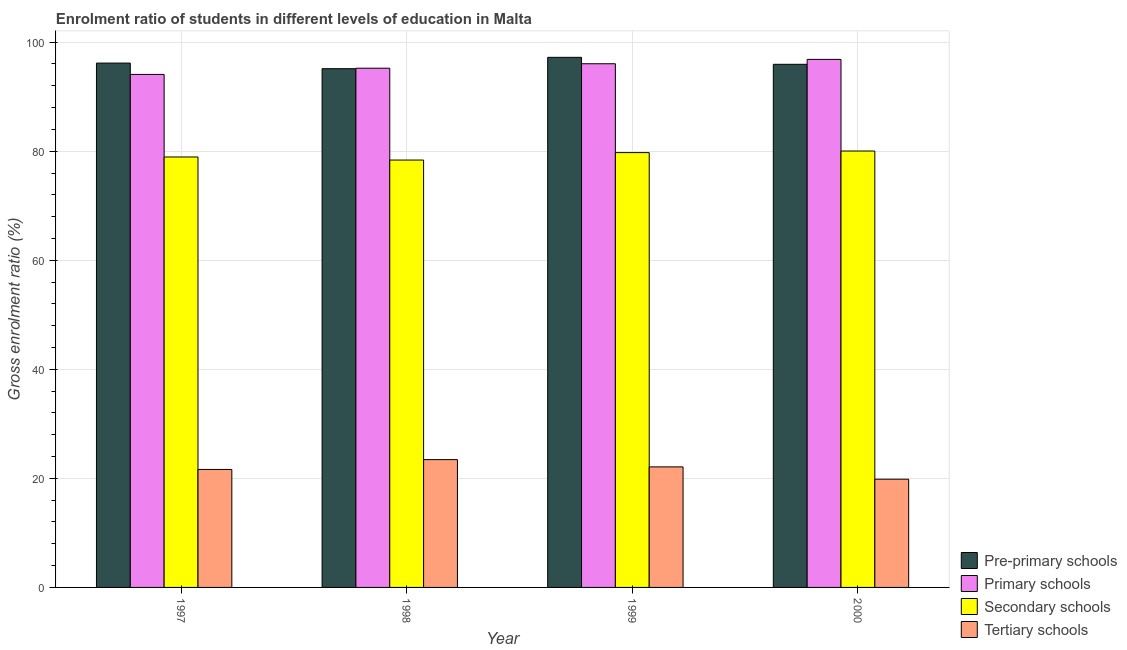How many bars are there on the 2nd tick from the right?
Your answer should be compact. 4. In how many cases, is the number of bars for a given year not equal to the number of legend labels?
Your response must be concise. 0. What is the gross enrolment ratio in pre-primary schools in 2000?
Offer a terse response. 95.94. Across all years, what is the maximum gross enrolment ratio in primary schools?
Your answer should be compact. 96.84. Across all years, what is the minimum gross enrolment ratio in tertiary schools?
Provide a short and direct response. 19.85. What is the total gross enrolment ratio in primary schools in the graph?
Your answer should be very brief. 382.19. What is the difference between the gross enrolment ratio in tertiary schools in 1998 and that in 1999?
Give a very brief answer. 1.33. What is the difference between the gross enrolment ratio in secondary schools in 1997 and the gross enrolment ratio in pre-primary schools in 1999?
Your answer should be compact. -0.8. What is the average gross enrolment ratio in primary schools per year?
Give a very brief answer. 95.55. In how many years, is the gross enrolment ratio in secondary schools greater than 64 %?
Provide a succinct answer. 4. What is the ratio of the gross enrolment ratio in secondary schools in 1997 to that in 1999?
Offer a very short reply. 0.99. What is the difference between the highest and the second highest gross enrolment ratio in primary schools?
Your answer should be compact. 0.8. What is the difference between the highest and the lowest gross enrolment ratio in primary schools?
Provide a succinct answer. 2.76. In how many years, is the gross enrolment ratio in pre-primary schools greater than the average gross enrolment ratio in pre-primary schools taken over all years?
Your answer should be compact. 2. Is the sum of the gross enrolment ratio in primary schools in 1997 and 1999 greater than the maximum gross enrolment ratio in tertiary schools across all years?
Your answer should be compact. Yes. Is it the case that in every year, the sum of the gross enrolment ratio in primary schools and gross enrolment ratio in pre-primary schools is greater than the sum of gross enrolment ratio in secondary schools and gross enrolment ratio in tertiary schools?
Your answer should be compact. Yes. What does the 2nd bar from the left in 1999 represents?
Your answer should be very brief. Primary schools. What does the 1st bar from the right in 1999 represents?
Ensure brevity in your answer.  Tertiary schools. Is it the case that in every year, the sum of the gross enrolment ratio in pre-primary schools and gross enrolment ratio in primary schools is greater than the gross enrolment ratio in secondary schools?
Provide a short and direct response. Yes. Are all the bars in the graph horizontal?
Keep it short and to the point. No. Are the values on the major ticks of Y-axis written in scientific E-notation?
Offer a terse response. No. Does the graph contain grids?
Your answer should be compact. Yes. Where does the legend appear in the graph?
Make the answer very short. Bottom right. How many legend labels are there?
Provide a succinct answer. 4. How are the legend labels stacked?
Give a very brief answer. Vertical. What is the title of the graph?
Provide a short and direct response. Enrolment ratio of students in different levels of education in Malta. What is the label or title of the X-axis?
Keep it short and to the point. Year. What is the label or title of the Y-axis?
Your answer should be very brief. Gross enrolment ratio (%). What is the Gross enrolment ratio (%) in Pre-primary schools in 1997?
Provide a succinct answer. 96.16. What is the Gross enrolment ratio (%) in Primary schools in 1997?
Your answer should be compact. 94.08. What is the Gross enrolment ratio (%) in Secondary schools in 1997?
Offer a very short reply. 78.94. What is the Gross enrolment ratio (%) of Tertiary schools in 1997?
Give a very brief answer. 21.64. What is the Gross enrolment ratio (%) in Pre-primary schools in 1998?
Keep it short and to the point. 95.13. What is the Gross enrolment ratio (%) of Primary schools in 1998?
Provide a short and direct response. 95.22. What is the Gross enrolment ratio (%) of Secondary schools in 1998?
Give a very brief answer. 78.38. What is the Gross enrolment ratio (%) in Tertiary schools in 1998?
Make the answer very short. 23.44. What is the Gross enrolment ratio (%) of Pre-primary schools in 1999?
Provide a succinct answer. 97.22. What is the Gross enrolment ratio (%) of Primary schools in 1999?
Ensure brevity in your answer.  96.04. What is the Gross enrolment ratio (%) in Secondary schools in 1999?
Offer a very short reply. 79.74. What is the Gross enrolment ratio (%) in Tertiary schools in 1999?
Ensure brevity in your answer.  22.11. What is the Gross enrolment ratio (%) of Pre-primary schools in 2000?
Your response must be concise. 95.94. What is the Gross enrolment ratio (%) in Primary schools in 2000?
Your response must be concise. 96.84. What is the Gross enrolment ratio (%) in Secondary schools in 2000?
Offer a terse response. 80.03. What is the Gross enrolment ratio (%) in Tertiary schools in 2000?
Ensure brevity in your answer.  19.85. Across all years, what is the maximum Gross enrolment ratio (%) in Pre-primary schools?
Offer a very short reply. 97.22. Across all years, what is the maximum Gross enrolment ratio (%) in Primary schools?
Provide a succinct answer. 96.84. Across all years, what is the maximum Gross enrolment ratio (%) of Secondary schools?
Ensure brevity in your answer.  80.03. Across all years, what is the maximum Gross enrolment ratio (%) of Tertiary schools?
Give a very brief answer. 23.44. Across all years, what is the minimum Gross enrolment ratio (%) of Pre-primary schools?
Your response must be concise. 95.13. Across all years, what is the minimum Gross enrolment ratio (%) in Primary schools?
Offer a terse response. 94.08. Across all years, what is the minimum Gross enrolment ratio (%) of Secondary schools?
Offer a very short reply. 78.38. Across all years, what is the minimum Gross enrolment ratio (%) in Tertiary schools?
Your response must be concise. 19.85. What is the total Gross enrolment ratio (%) in Pre-primary schools in the graph?
Keep it short and to the point. 384.45. What is the total Gross enrolment ratio (%) in Primary schools in the graph?
Your answer should be compact. 382.19. What is the total Gross enrolment ratio (%) in Secondary schools in the graph?
Give a very brief answer. 317.09. What is the total Gross enrolment ratio (%) in Tertiary schools in the graph?
Ensure brevity in your answer.  87.03. What is the difference between the Gross enrolment ratio (%) in Pre-primary schools in 1997 and that in 1998?
Your answer should be compact. 1.03. What is the difference between the Gross enrolment ratio (%) of Primary schools in 1997 and that in 1998?
Offer a very short reply. -1.14. What is the difference between the Gross enrolment ratio (%) in Secondary schools in 1997 and that in 1998?
Your response must be concise. 0.56. What is the difference between the Gross enrolment ratio (%) in Tertiary schools in 1997 and that in 1998?
Your response must be concise. -1.8. What is the difference between the Gross enrolment ratio (%) of Pre-primary schools in 1997 and that in 1999?
Ensure brevity in your answer.  -1.06. What is the difference between the Gross enrolment ratio (%) of Primary schools in 1997 and that in 1999?
Offer a terse response. -1.96. What is the difference between the Gross enrolment ratio (%) in Secondary schools in 1997 and that in 1999?
Provide a succinct answer. -0.8. What is the difference between the Gross enrolment ratio (%) of Tertiary schools in 1997 and that in 1999?
Your answer should be very brief. -0.47. What is the difference between the Gross enrolment ratio (%) in Pre-primary schools in 1997 and that in 2000?
Your response must be concise. 0.22. What is the difference between the Gross enrolment ratio (%) of Primary schools in 1997 and that in 2000?
Make the answer very short. -2.76. What is the difference between the Gross enrolment ratio (%) in Secondary schools in 1997 and that in 2000?
Your response must be concise. -1.09. What is the difference between the Gross enrolment ratio (%) of Tertiary schools in 1997 and that in 2000?
Provide a succinct answer. 1.79. What is the difference between the Gross enrolment ratio (%) in Pre-primary schools in 1998 and that in 1999?
Your answer should be compact. -2.08. What is the difference between the Gross enrolment ratio (%) of Primary schools in 1998 and that in 1999?
Provide a succinct answer. -0.82. What is the difference between the Gross enrolment ratio (%) in Secondary schools in 1998 and that in 1999?
Make the answer very short. -1.36. What is the difference between the Gross enrolment ratio (%) of Tertiary schools in 1998 and that in 1999?
Your response must be concise. 1.33. What is the difference between the Gross enrolment ratio (%) in Pre-primary schools in 1998 and that in 2000?
Offer a very short reply. -0.8. What is the difference between the Gross enrolment ratio (%) in Primary schools in 1998 and that in 2000?
Your answer should be compact. -1.62. What is the difference between the Gross enrolment ratio (%) of Secondary schools in 1998 and that in 2000?
Your response must be concise. -1.66. What is the difference between the Gross enrolment ratio (%) of Tertiary schools in 1998 and that in 2000?
Your answer should be compact. 3.59. What is the difference between the Gross enrolment ratio (%) in Pre-primary schools in 1999 and that in 2000?
Your response must be concise. 1.28. What is the difference between the Gross enrolment ratio (%) of Primary schools in 1999 and that in 2000?
Offer a very short reply. -0.8. What is the difference between the Gross enrolment ratio (%) in Secondary schools in 1999 and that in 2000?
Give a very brief answer. -0.29. What is the difference between the Gross enrolment ratio (%) in Tertiary schools in 1999 and that in 2000?
Ensure brevity in your answer.  2.26. What is the difference between the Gross enrolment ratio (%) of Pre-primary schools in 1997 and the Gross enrolment ratio (%) of Primary schools in 1998?
Ensure brevity in your answer.  0.94. What is the difference between the Gross enrolment ratio (%) of Pre-primary schools in 1997 and the Gross enrolment ratio (%) of Secondary schools in 1998?
Give a very brief answer. 17.78. What is the difference between the Gross enrolment ratio (%) in Pre-primary schools in 1997 and the Gross enrolment ratio (%) in Tertiary schools in 1998?
Offer a very short reply. 72.72. What is the difference between the Gross enrolment ratio (%) of Primary schools in 1997 and the Gross enrolment ratio (%) of Secondary schools in 1998?
Your answer should be compact. 15.71. What is the difference between the Gross enrolment ratio (%) of Primary schools in 1997 and the Gross enrolment ratio (%) of Tertiary schools in 1998?
Your answer should be compact. 70.64. What is the difference between the Gross enrolment ratio (%) in Secondary schools in 1997 and the Gross enrolment ratio (%) in Tertiary schools in 1998?
Ensure brevity in your answer.  55.5. What is the difference between the Gross enrolment ratio (%) in Pre-primary schools in 1997 and the Gross enrolment ratio (%) in Primary schools in 1999?
Offer a very short reply. 0.12. What is the difference between the Gross enrolment ratio (%) of Pre-primary schools in 1997 and the Gross enrolment ratio (%) of Secondary schools in 1999?
Provide a short and direct response. 16.42. What is the difference between the Gross enrolment ratio (%) in Pre-primary schools in 1997 and the Gross enrolment ratio (%) in Tertiary schools in 1999?
Offer a terse response. 74.05. What is the difference between the Gross enrolment ratio (%) of Primary schools in 1997 and the Gross enrolment ratio (%) of Secondary schools in 1999?
Keep it short and to the point. 14.34. What is the difference between the Gross enrolment ratio (%) in Primary schools in 1997 and the Gross enrolment ratio (%) in Tertiary schools in 1999?
Offer a terse response. 71.97. What is the difference between the Gross enrolment ratio (%) in Secondary schools in 1997 and the Gross enrolment ratio (%) in Tertiary schools in 1999?
Your response must be concise. 56.83. What is the difference between the Gross enrolment ratio (%) in Pre-primary schools in 1997 and the Gross enrolment ratio (%) in Primary schools in 2000?
Ensure brevity in your answer.  -0.68. What is the difference between the Gross enrolment ratio (%) of Pre-primary schools in 1997 and the Gross enrolment ratio (%) of Secondary schools in 2000?
Your answer should be very brief. 16.13. What is the difference between the Gross enrolment ratio (%) of Pre-primary schools in 1997 and the Gross enrolment ratio (%) of Tertiary schools in 2000?
Your answer should be compact. 76.31. What is the difference between the Gross enrolment ratio (%) in Primary schools in 1997 and the Gross enrolment ratio (%) in Secondary schools in 2000?
Your response must be concise. 14.05. What is the difference between the Gross enrolment ratio (%) of Primary schools in 1997 and the Gross enrolment ratio (%) of Tertiary schools in 2000?
Offer a terse response. 74.23. What is the difference between the Gross enrolment ratio (%) in Secondary schools in 1997 and the Gross enrolment ratio (%) in Tertiary schools in 2000?
Provide a succinct answer. 59.09. What is the difference between the Gross enrolment ratio (%) of Pre-primary schools in 1998 and the Gross enrolment ratio (%) of Primary schools in 1999?
Your response must be concise. -0.91. What is the difference between the Gross enrolment ratio (%) in Pre-primary schools in 1998 and the Gross enrolment ratio (%) in Secondary schools in 1999?
Give a very brief answer. 15.39. What is the difference between the Gross enrolment ratio (%) of Pre-primary schools in 1998 and the Gross enrolment ratio (%) of Tertiary schools in 1999?
Give a very brief answer. 73.03. What is the difference between the Gross enrolment ratio (%) of Primary schools in 1998 and the Gross enrolment ratio (%) of Secondary schools in 1999?
Provide a succinct answer. 15.48. What is the difference between the Gross enrolment ratio (%) of Primary schools in 1998 and the Gross enrolment ratio (%) of Tertiary schools in 1999?
Offer a terse response. 73.11. What is the difference between the Gross enrolment ratio (%) in Secondary schools in 1998 and the Gross enrolment ratio (%) in Tertiary schools in 1999?
Give a very brief answer. 56.27. What is the difference between the Gross enrolment ratio (%) in Pre-primary schools in 1998 and the Gross enrolment ratio (%) in Primary schools in 2000?
Make the answer very short. -1.71. What is the difference between the Gross enrolment ratio (%) of Pre-primary schools in 1998 and the Gross enrolment ratio (%) of Secondary schools in 2000?
Keep it short and to the point. 15.1. What is the difference between the Gross enrolment ratio (%) of Pre-primary schools in 1998 and the Gross enrolment ratio (%) of Tertiary schools in 2000?
Provide a succinct answer. 75.29. What is the difference between the Gross enrolment ratio (%) in Primary schools in 1998 and the Gross enrolment ratio (%) in Secondary schools in 2000?
Provide a short and direct response. 15.19. What is the difference between the Gross enrolment ratio (%) of Primary schools in 1998 and the Gross enrolment ratio (%) of Tertiary schools in 2000?
Offer a very short reply. 75.37. What is the difference between the Gross enrolment ratio (%) of Secondary schools in 1998 and the Gross enrolment ratio (%) of Tertiary schools in 2000?
Your answer should be very brief. 58.53. What is the difference between the Gross enrolment ratio (%) of Pre-primary schools in 1999 and the Gross enrolment ratio (%) of Primary schools in 2000?
Make the answer very short. 0.38. What is the difference between the Gross enrolment ratio (%) of Pre-primary schools in 1999 and the Gross enrolment ratio (%) of Secondary schools in 2000?
Keep it short and to the point. 17.18. What is the difference between the Gross enrolment ratio (%) in Pre-primary schools in 1999 and the Gross enrolment ratio (%) in Tertiary schools in 2000?
Offer a terse response. 77.37. What is the difference between the Gross enrolment ratio (%) in Primary schools in 1999 and the Gross enrolment ratio (%) in Secondary schools in 2000?
Keep it short and to the point. 16.01. What is the difference between the Gross enrolment ratio (%) in Primary schools in 1999 and the Gross enrolment ratio (%) in Tertiary schools in 2000?
Provide a short and direct response. 76.19. What is the difference between the Gross enrolment ratio (%) in Secondary schools in 1999 and the Gross enrolment ratio (%) in Tertiary schools in 2000?
Provide a short and direct response. 59.89. What is the average Gross enrolment ratio (%) of Pre-primary schools per year?
Ensure brevity in your answer.  96.11. What is the average Gross enrolment ratio (%) in Primary schools per year?
Offer a terse response. 95.55. What is the average Gross enrolment ratio (%) of Secondary schools per year?
Make the answer very short. 79.27. What is the average Gross enrolment ratio (%) in Tertiary schools per year?
Make the answer very short. 21.76. In the year 1997, what is the difference between the Gross enrolment ratio (%) of Pre-primary schools and Gross enrolment ratio (%) of Primary schools?
Your answer should be compact. 2.08. In the year 1997, what is the difference between the Gross enrolment ratio (%) of Pre-primary schools and Gross enrolment ratio (%) of Secondary schools?
Your answer should be very brief. 17.22. In the year 1997, what is the difference between the Gross enrolment ratio (%) of Pre-primary schools and Gross enrolment ratio (%) of Tertiary schools?
Provide a succinct answer. 74.52. In the year 1997, what is the difference between the Gross enrolment ratio (%) of Primary schools and Gross enrolment ratio (%) of Secondary schools?
Keep it short and to the point. 15.14. In the year 1997, what is the difference between the Gross enrolment ratio (%) in Primary schools and Gross enrolment ratio (%) in Tertiary schools?
Your answer should be very brief. 72.45. In the year 1997, what is the difference between the Gross enrolment ratio (%) in Secondary schools and Gross enrolment ratio (%) in Tertiary schools?
Keep it short and to the point. 57.3. In the year 1998, what is the difference between the Gross enrolment ratio (%) in Pre-primary schools and Gross enrolment ratio (%) in Primary schools?
Provide a short and direct response. -0.09. In the year 1998, what is the difference between the Gross enrolment ratio (%) of Pre-primary schools and Gross enrolment ratio (%) of Secondary schools?
Make the answer very short. 16.76. In the year 1998, what is the difference between the Gross enrolment ratio (%) of Pre-primary schools and Gross enrolment ratio (%) of Tertiary schools?
Ensure brevity in your answer.  71.7. In the year 1998, what is the difference between the Gross enrolment ratio (%) in Primary schools and Gross enrolment ratio (%) in Secondary schools?
Provide a short and direct response. 16.84. In the year 1998, what is the difference between the Gross enrolment ratio (%) in Primary schools and Gross enrolment ratio (%) in Tertiary schools?
Provide a succinct answer. 71.78. In the year 1998, what is the difference between the Gross enrolment ratio (%) in Secondary schools and Gross enrolment ratio (%) in Tertiary schools?
Your answer should be very brief. 54.94. In the year 1999, what is the difference between the Gross enrolment ratio (%) of Pre-primary schools and Gross enrolment ratio (%) of Primary schools?
Provide a succinct answer. 1.17. In the year 1999, what is the difference between the Gross enrolment ratio (%) in Pre-primary schools and Gross enrolment ratio (%) in Secondary schools?
Offer a very short reply. 17.48. In the year 1999, what is the difference between the Gross enrolment ratio (%) of Pre-primary schools and Gross enrolment ratio (%) of Tertiary schools?
Your answer should be very brief. 75.11. In the year 1999, what is the difference between the Gross enrolment ratio (%) in Primary schools and Gross enrolment ratio (%) in Secondary schools?
Give a very brief answer. 16.3. In the year 1999, what is the difference between the Gross enrolment ratio (%) in Primary schools and Gross enrolment ratio (%) in Tertiary schools?
Provide a short and direct response. 73.93. In the year 1999, what is the difference between the Gross enrolment ratio (%) of Secondary schools and Gross enrolment ratio (%) of Tertiary schools?
Your answer should be very brief. 57.63. In the year 2000, what is the difference between the Gross enrolment ratio (%) of Pre-primary schools and Gross enrolment ratio (%) of Primary schools?
Give a very brief answer. -0.9. In the year 2000, what is the difference between the Gross enrolment ratio (%) of Pre-primary schools and Gross enrolment ratio (%) of Secondary schools?
Your response must be concise. 15.9. In the year 2000, what is the difference between the Gross enrolment ratio (%) in Pre-primary schools and Gross enrolment ratio (%) in Tertiary schools?
Give a very brief answer. 76.09. In the year 2000, what is the difference between the Gross enrolment ratio (%) in Primary schools and Gross enrolment ratio (%) in Secondary schools?
Offer a terse response. 16.81. In the year 2000, what is the difference between the Gross enrolment ratio (%) in Primary schools and Gross enrolment ratio (%) in Tertiary schools?
Ensure brevity in your answer.  76.99. In the year 2000, what is the difference between the Gross enrolment ratio (%) in Secondary schools and Gross enrolment ratio (%) in Tertiary schools?
Provide a short and direct response. 60.19. What is the ratio of the Gross enrolment ratio (%) in Pre-primary schools in 1997 to that in 1998?
Offer a very short reply. 1.01. What is the ratio of the Gross enrolment ratio (%) in Primary schools in 1997 to that in 1998?
Give a very brief answer. 0.99. What is the ratio of the Gross enrolment ratio (%) in Secondary schools in 1997 to that in 1998?
Your answer should be compact. 1.01. What is the ratio of the Gross enrolment ratio (%) of Pre-primary schools in 1997 to that in 1999?
Your answer should be very brief. 0.99. What is the ratio of the Gross enrolment ratio (%) in Primary schools in 1997 to that in 1999?
Ensure brevity in your answer.  0.98. What is the ratio of the Gross enrolment ratio (%) of Secondary schools in 1997 to that in 1999?
Provide a succinct answer. 0.99. What is the ratio of the Gross enrolment ratio (%) of Tertiary schools in 1997 to that in 1999?
Your answer should be compact. 0.98. What is the ratio of the Gross enrolment ratio (%) in Primary schools in 1997 to that in 2000?
Provide a succinct answer. 0.97. What is the ratio of the Gross enrolment ratio (%) of Secondary schools in 1997 to that in 2000?
Your response must be concise. 0.99. What is the ratio of the Gross enrolment ratio (%) of Tertiary schools in 1997 to that in 2000?
Your answer should be compact. 1.09. What is the ratio of the Gross enrolment ratio (%) of Pre-primary schools in 1998 to that in 1999?
Keep it short and to the point. 0.98. What is the ratio of the Gross enrolment ratio (%) in Primary schools in 1998 to that in 1999?
Your response must be concise. 0.99. What is the ratio of the Gross enrolment ratio (%) of Secondary schools in 1998 to that in 1999?
Make the answer very short. 0.98. What is the ratio of the Gross enrolment ratio (%) of Tertiary schools in 1998 to that in 1999?
Ensure brevity in your answer.  1.06. What is the ratio of the Gross enrolment ratio (%) in Pre-primary schools in 1998 to that in 2000?
Offer a terse response. 0.99. What is the ratio of the Gross enrolment ratio (%) in Primary schools in 1998 to that in 2000?
Make the answer very short. 0.98. What is the ratio of the Gross enrolment ratio (%) of Secondary schools in 1998 to that in 2000?
Ensure brevity in your answer.  0.98. What is the ratio of the Gross enrolment ratio (%) of Tertiary schools in 1998 to that in 2000?
Provide a succinct answer. 1.18. What is the ratio of the Gross enrolment ratio (%) in Pre-primary schools in 1999 to that in 2000?
Provide a short and direct response. 1.01. What is the ratio of the Gross enrolment ratio (%) in Primary schools in 1999 to that in 2000?
Provide a short and direct response. 0.99. What is the ratio of the Gross enrolment ratio (%) in Secondary schools in 1999 to that in 2000?
Offer a very short reply. 1. What is the ratio of the Gross enrolment ratio (%) in Tertiary schools in 1999 to that in 2000?
Make the answer very short. 1.11. What is the difference between the highest and the second highest Gross enrolment ratio (%) in Pre-primary schools?
Provide a short and direct response. 1.06. What is the difference between the highest and the second highest Gross enrolment ratio (%) in Primary schools?
Give a very brief answer. 0.8. What is the difference between the highest and the second highest Gross enrolment ratio (%) of Secondary schools?
Provide a succinct answer. 0.29. What is the difference between the highest and the second highest Gross enrolment ratio (%) of Tertiary schools?
Keep it short and to the point. 1.33. What is the difference between the highest and the lowest Gross enrolment ratio (%) in Pre-primary schools?
Offer a terse response. 2.08. What is the difference between the highest and the lowest Gross enrolment ratio (%) in Primary schools?
Provide a succinct answer. 2.76. What is the difference between the highest and the lowest Gross enrolment ratio (%) of Secondary schools?
Your response must be concise. 1.66. What is the difference between the highest and the lowest Gross enrolment ratio (%) of Tertiary schools?
Provide a short and direct response. 3.59. 